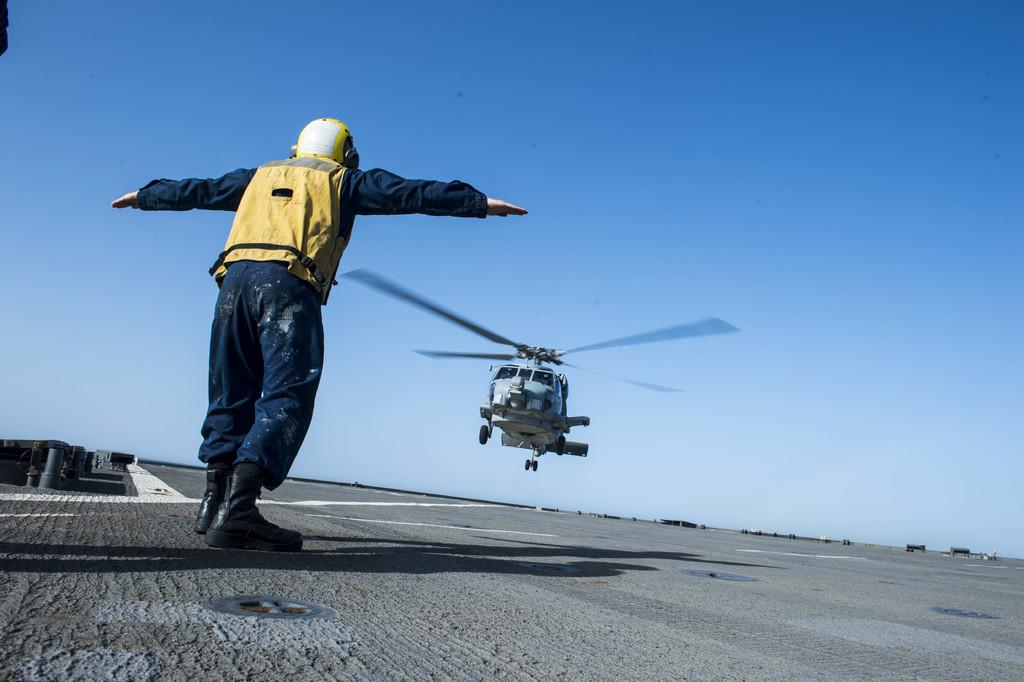What is the main subject of the image? The main subject of the image is a plane. What is the plane doing in the image? The plane is flying from a runway. Is there anyone else in the image besides the plane? Yes, there is a person standing in front of the plane. What is the person doing in the image? The person is stretching their hands. What type of carriage is being pulled by the horse in the image? There is no carriage or horse present in the image; it features a plane flying from a runway and a person stretching their hands. 